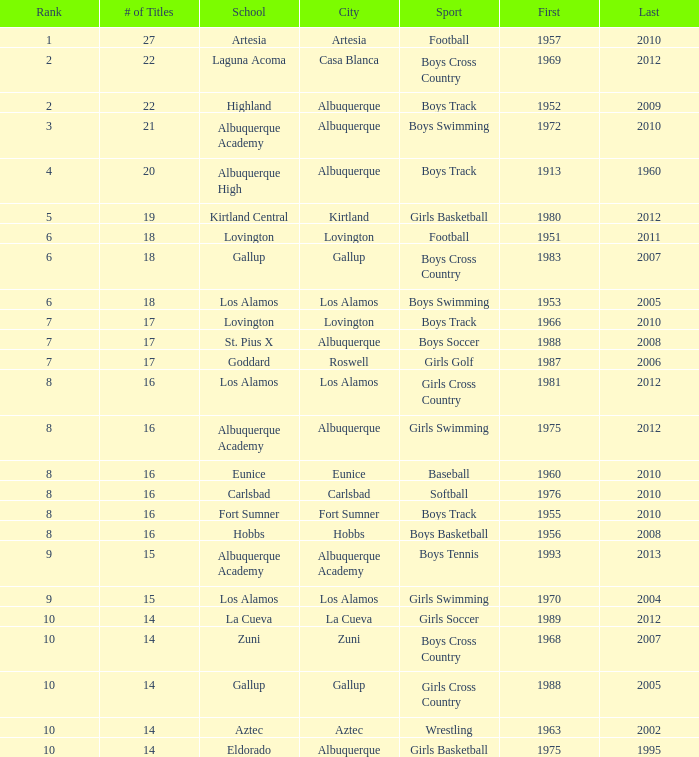In what city is the school possessing under 17 boys basketball trophies, with the final championship taking place after 2005? Hobbs. 